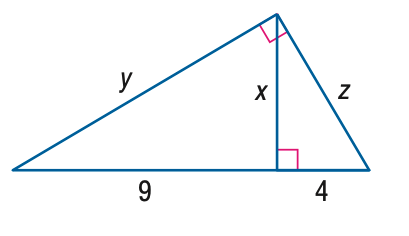Question: Find x.
Choices:
A. 1.5
B. 4
C. 6
D. 9
Answer with the letter. Answer: C 